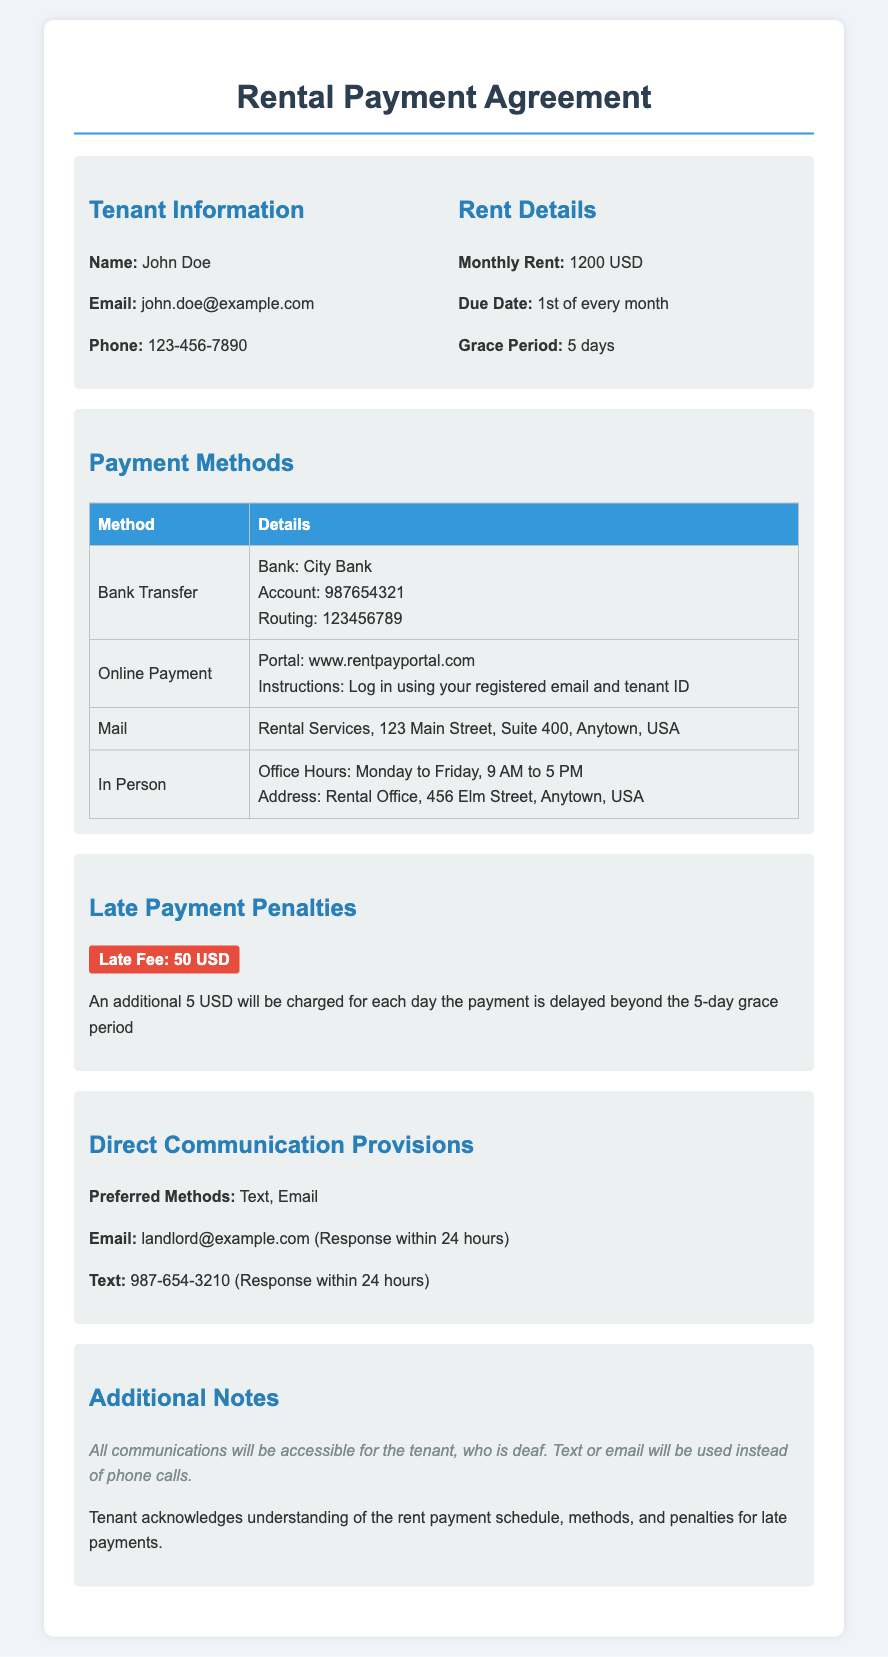What is the monthly rent? The monthly rent is specified in the document as 1200 USD.
Answer: 1200 USD What is the due date for rent payment? The due date for rent payment is clearly stated as the 1st of every month.
Answer: 1st of every month How long is the grace period for late payments? The grace period for late payments is outlined in the document as 5 days.
Answer: 5 days What penalty is charged for late payment? The document specifies that a late fee of 50 USD will be charged.
Answer: 50 USD How much will additional charges be for each day of delay after the grace period? The document indicates an additional charge of 5 USD will be applied for each day of delay beyond the grace period.
Answer: 5 USD What are the preferred methods of communication? The preferred methods of communication for the tenant are stated as text and email.
Answer: Text, Email What is the response time for email communication? As per the document, the response time for email communication is within 24 hours.
Answer: 24 hours What is the address for mailing rent payments? The document provides the mailing address for rent payments as Rental Services, 123 Main Street, Suite 400, Anytown, USA.
Answer: Rental Services, 123 Main Street, Suite 400, Anytown, USA What is the consequence for not paying within the grace period? It states that if payment is delayed beyond the grace period, a late fee and additional charges will apply.
Answer: Late fee and additional charges 